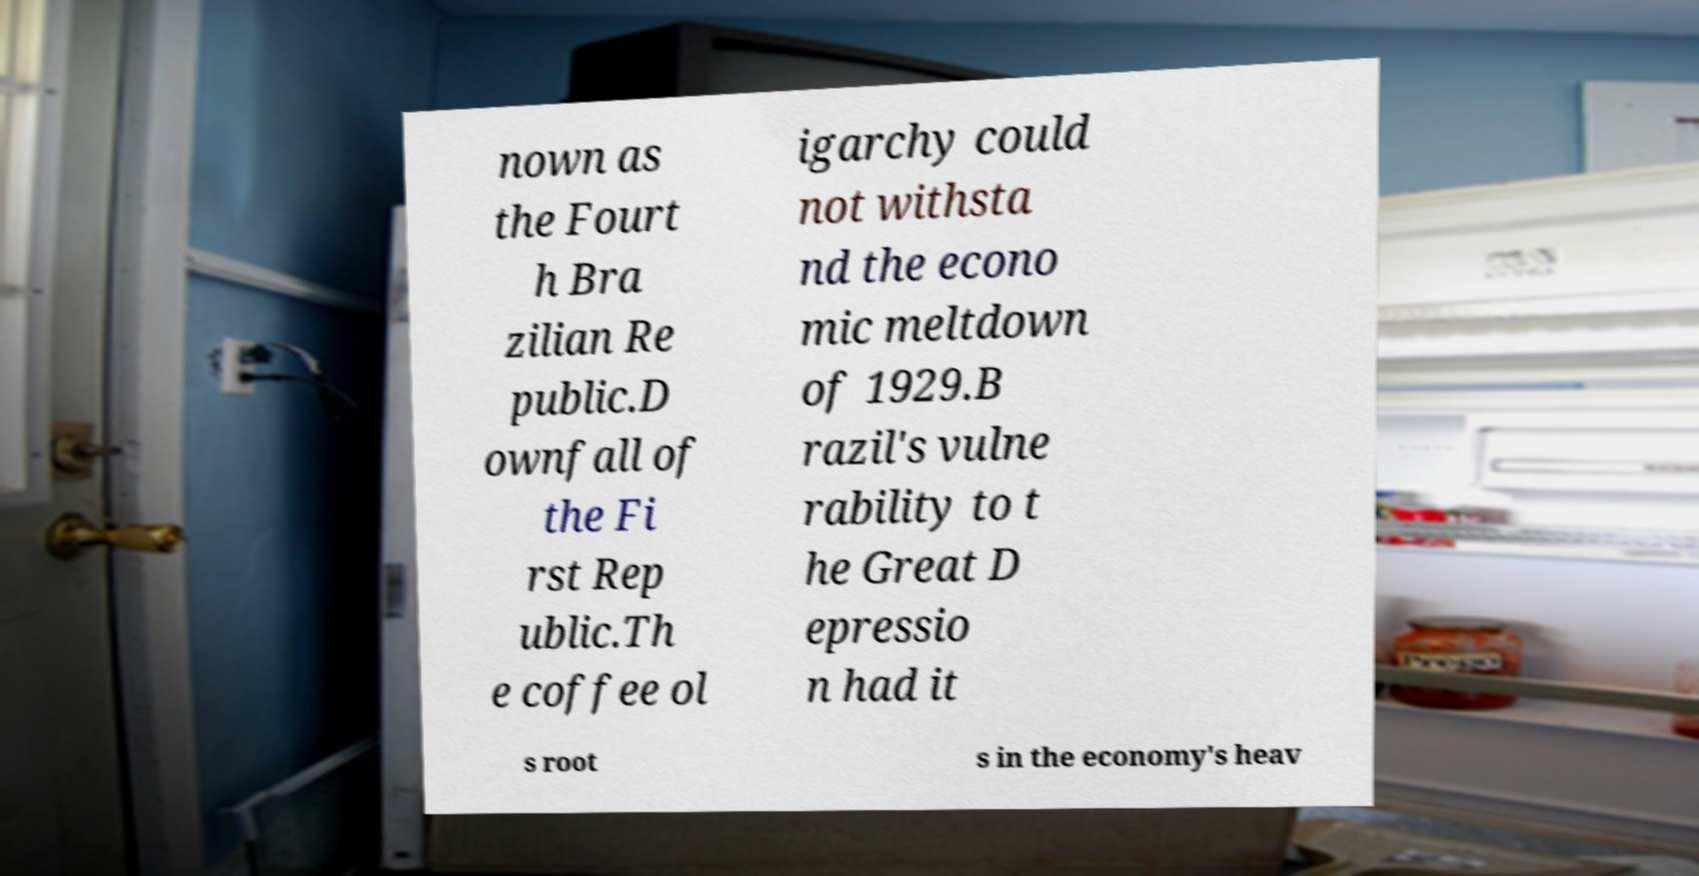Can you read and provide the text displayed in the image?This photo seems to have some interesting text. Can you extract and type it out for me? nown as the Fourt h Bra zilian Re public.D ownfall of the Fi rst Rep ublic.Th e coffee ol igarchy could not withsta nd the econo mic meltdown of 1929.B razil's vulne rability to t he Great D epressio n had it s root s in the economy's heav 